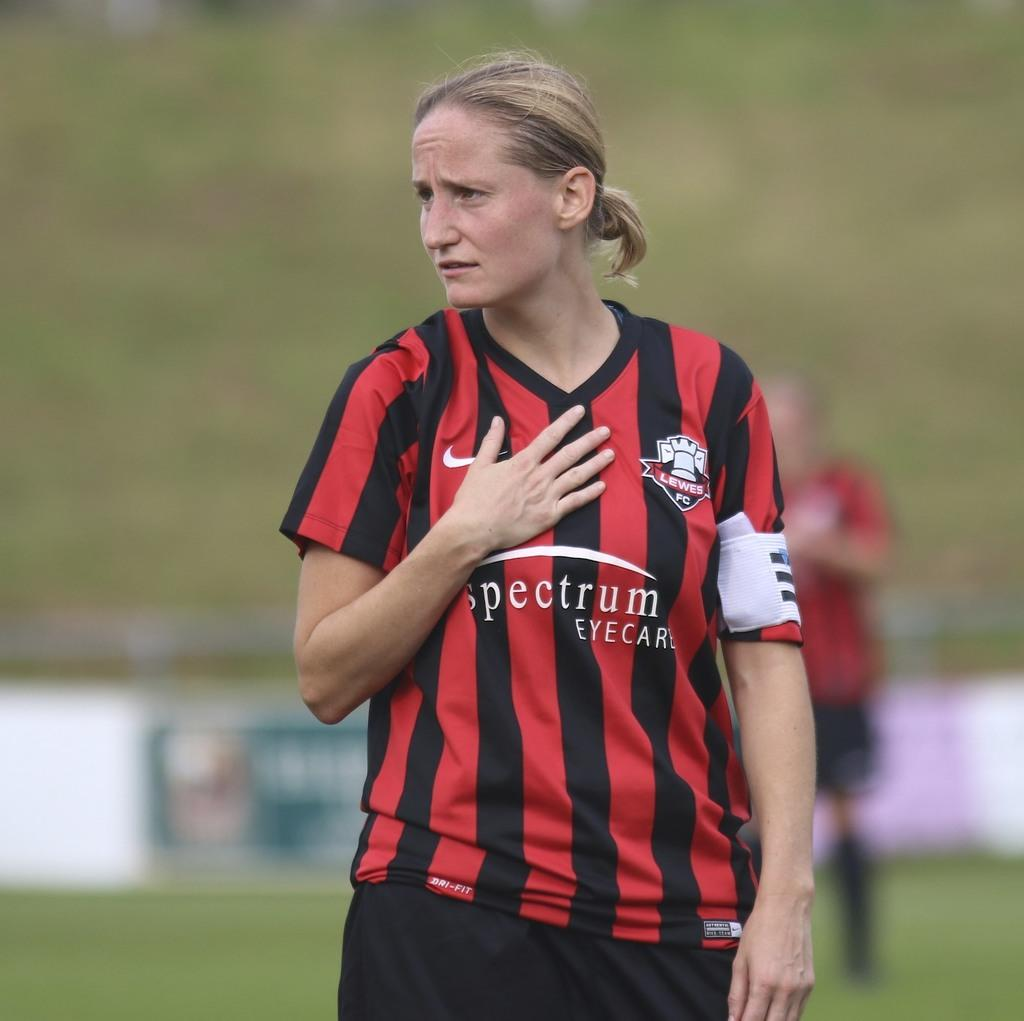Provide a one-sentence caption for the provided image. Soccer player wearing a red and black shirt that says Spectrum on it. 